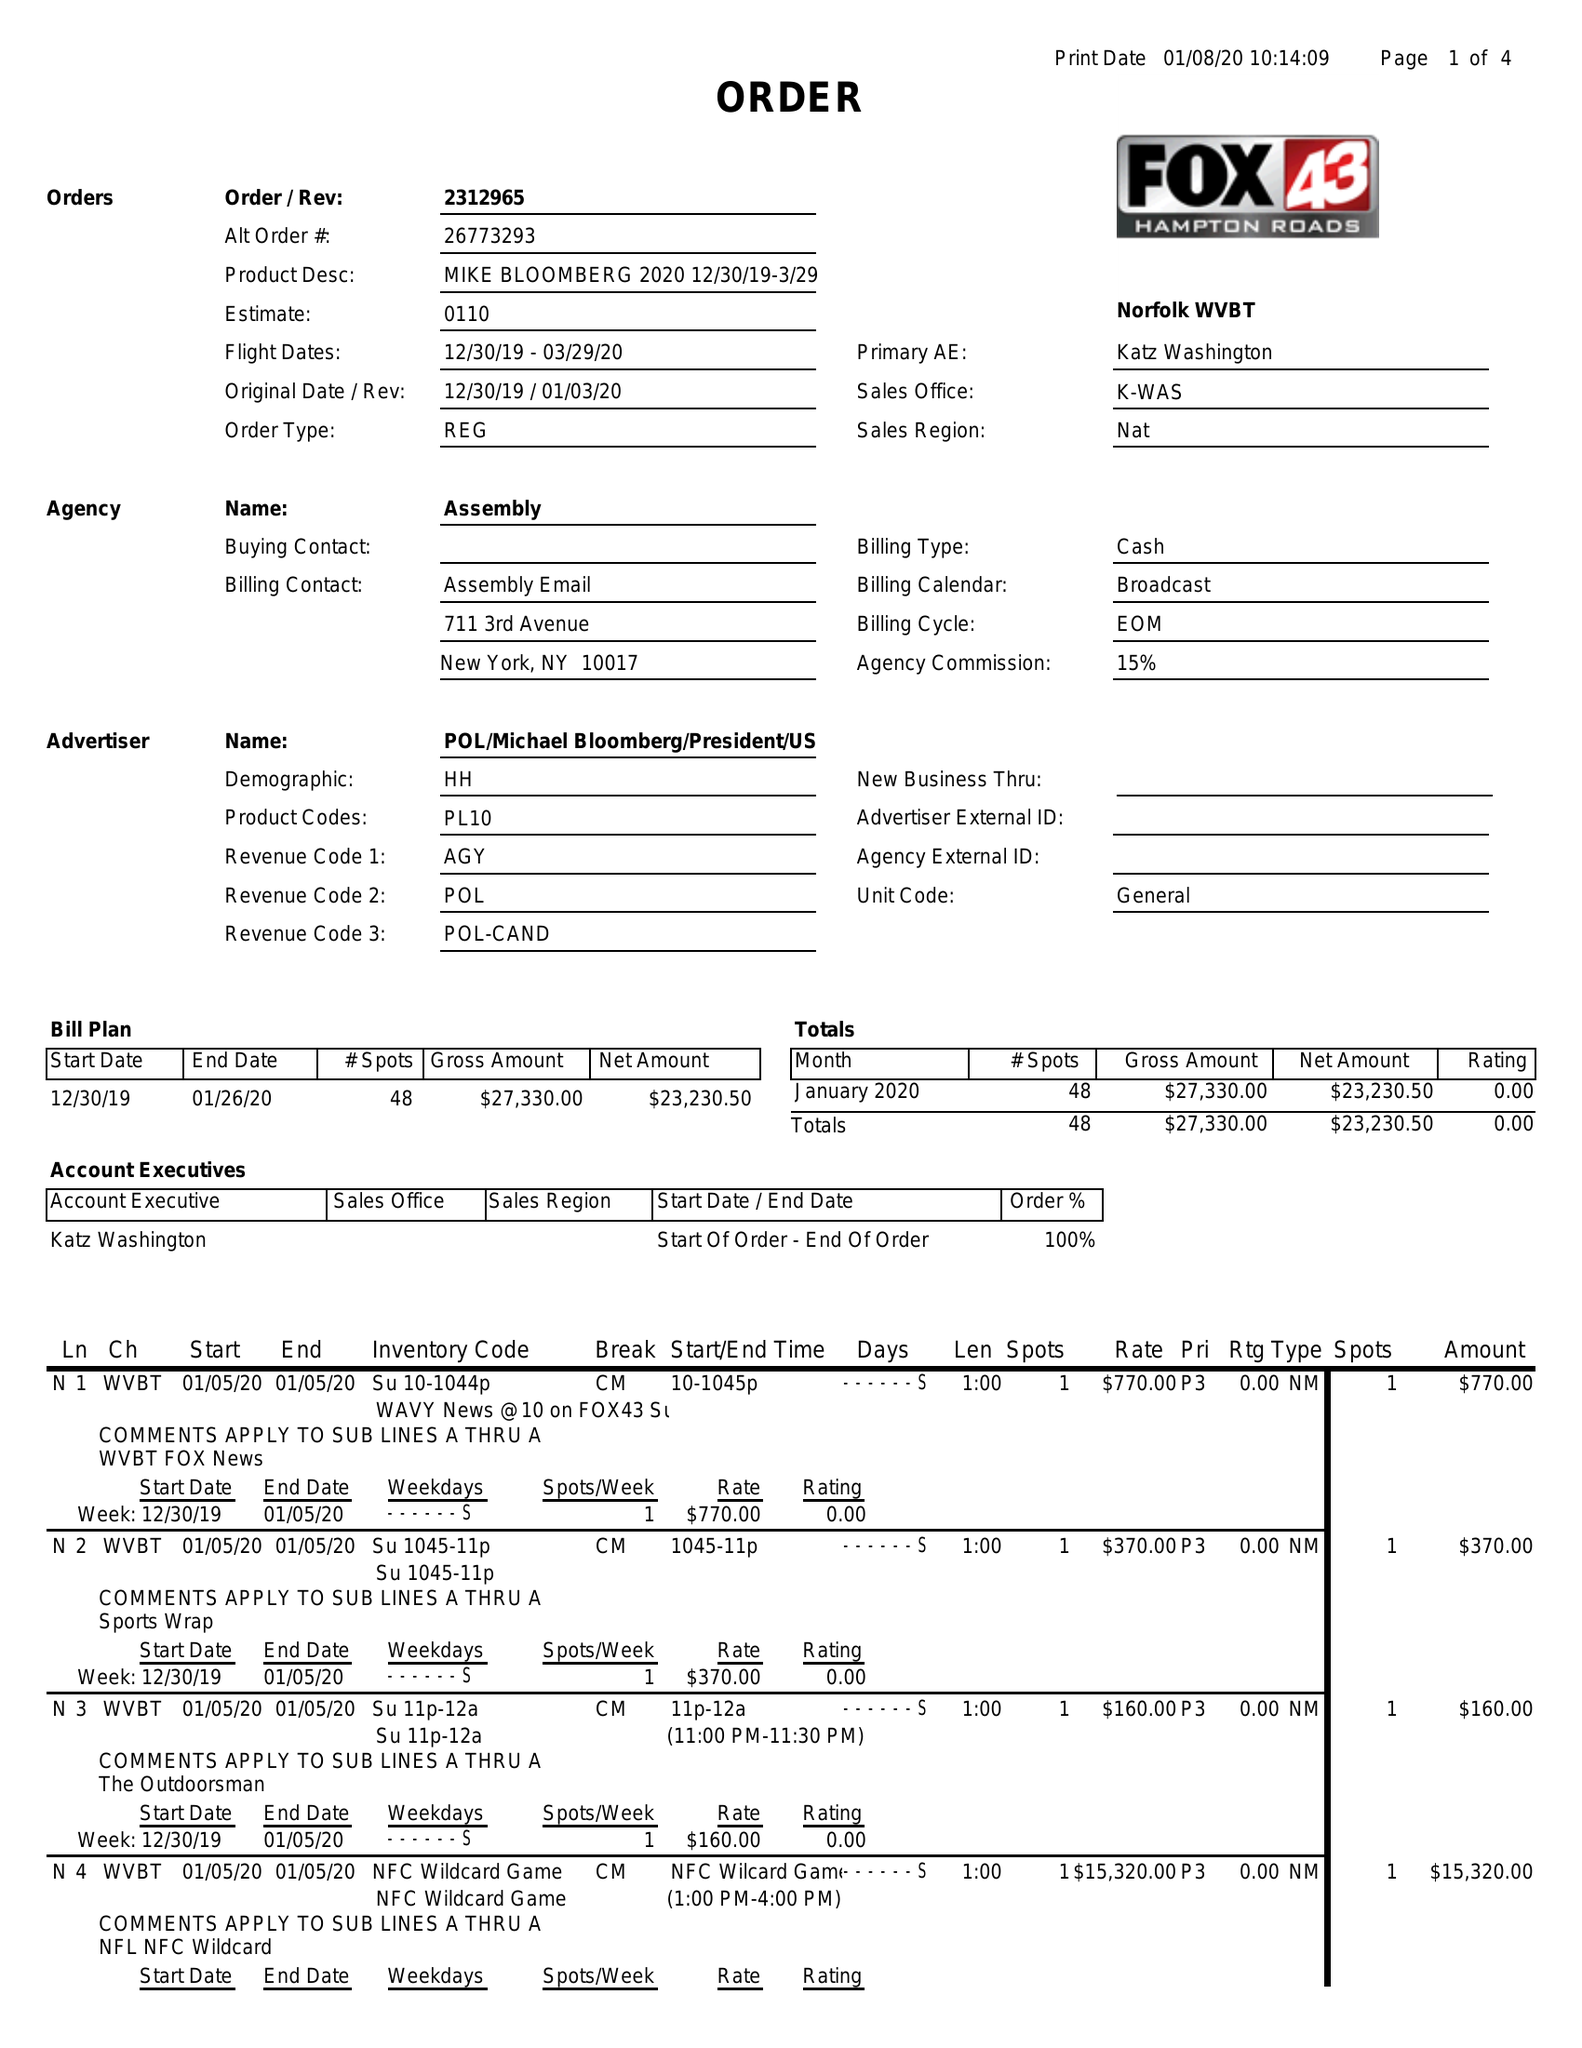What is the value for the advertiser?
Answer the question using a single word or phrase. POL/MICHAELBLOOMBERG/PRESIDENT/US/DEM 